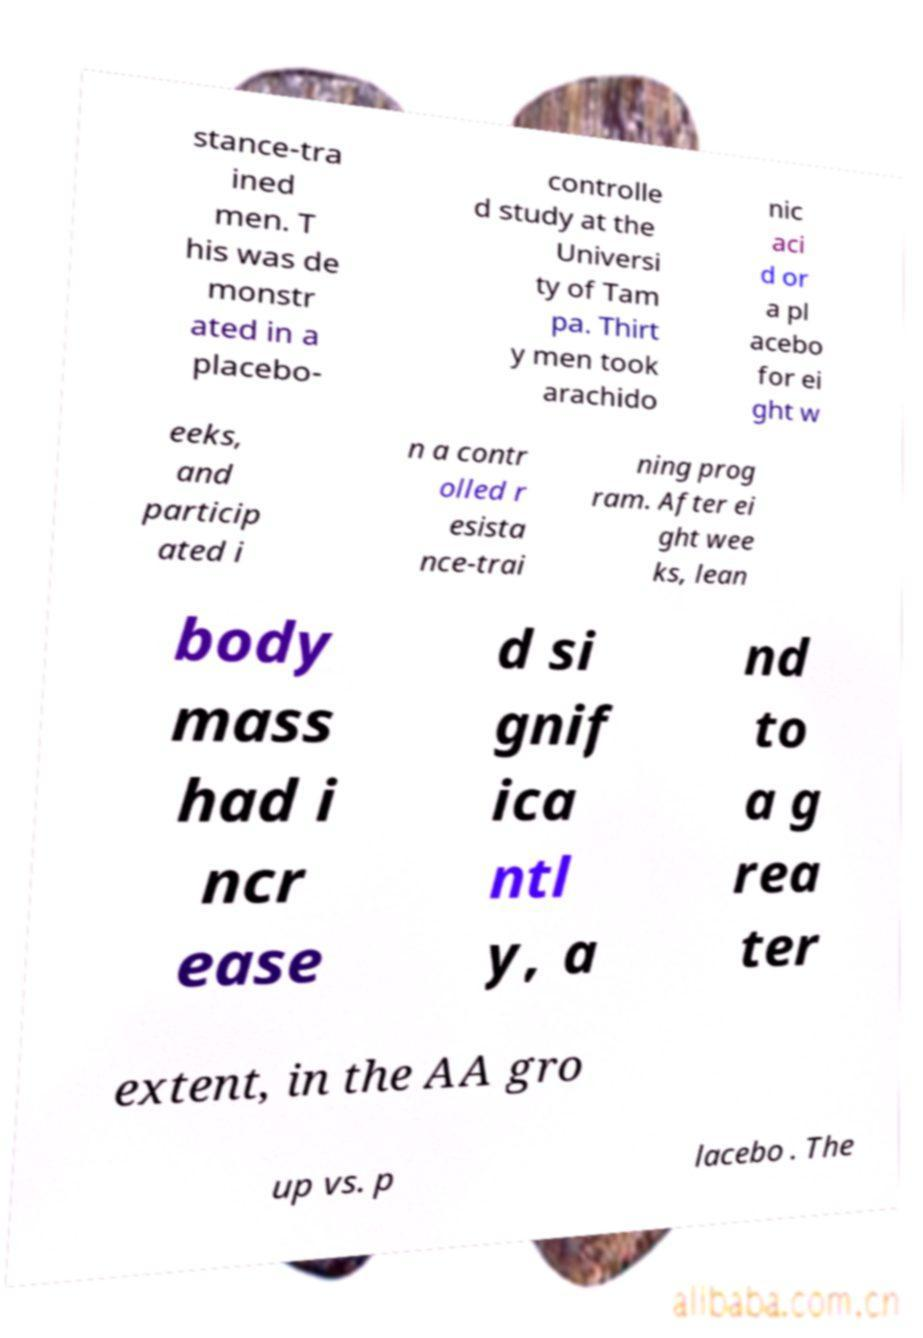Can you read and provide the text displayed in the image?This photo seems to have some interesting text. Can you extract and type it out for me? stance-tra ined men. T his was de monstr ated in a placebo- controlle d study at the Universi ty of Tam pa. Thirt y men took arachido nic aci d or a pl acebo for ei ght w eeks, and particip ated i n a contr olled r esista nce-trai ning prog ram. After ei ght wee ks, lean body mass had i ncr ease d si gnif ica ntl y, a nd to a g rea ter extent, in the AA gro up vs. p lacebo . The 